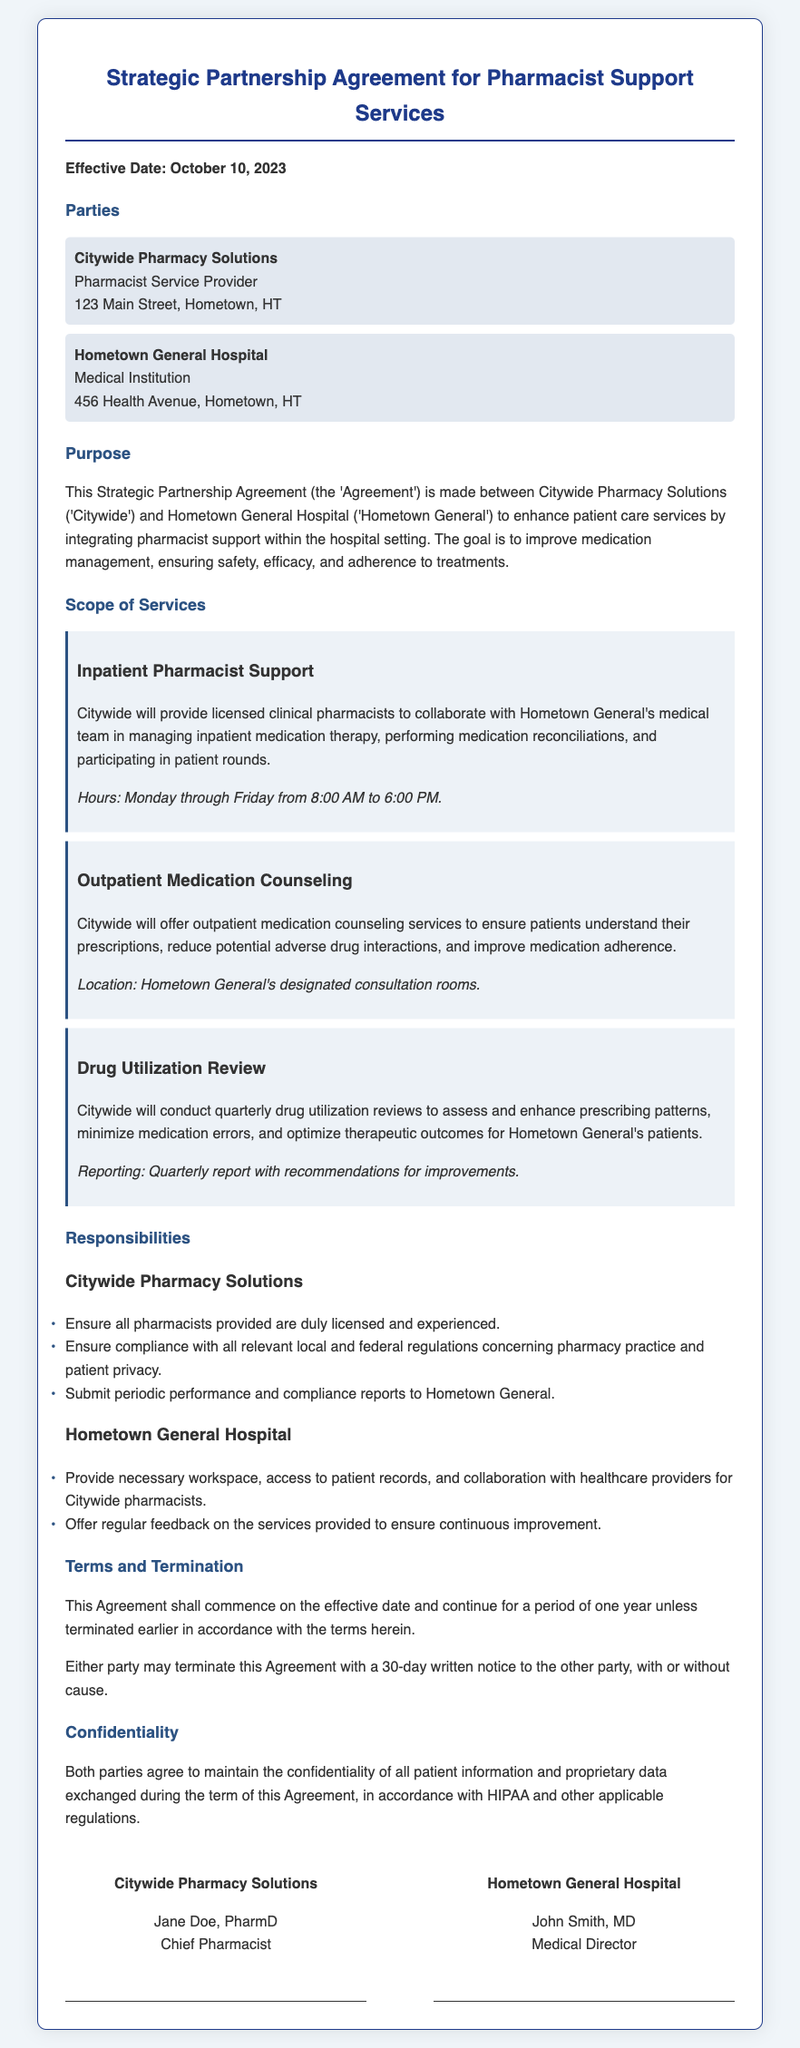What is the effective date of the agreement? The effective date is clearly stated at the beginning of the document as October 10, 2023.
Answer: October 10, 2023 Who is the Chief Pharmacist at Citywide Pharmacy Solutions? The document specifies that Jane Doe, PharmD, holds the position of Chief Pharmacist.
Answer: Jane Doe, PharmD How often will drug utilization reviews be conducted? The agreement outlines that these reviews will occur quarterly.
Answer: Quarterly What is one of the responsibilities of Hometown General Hospital? The document lists providing necessary workspace and access to patient records as a responsibility of Hometown General.
Answer: Provide necessary workspace What is the duration of the agreement? The terms state that the agreement continues for a period of one year unless terminated earlier.
Answer: One year What is required for either party to terminate the agreement? The document states that a 30-day written notice is required for termination by either party.
Answer: 30-day written notice Where is Citywide Pharmacy Solutions located? The document provides the address of Citywide Pharmacy Solutions as 123 Main Street, Hometown, HT.
Answer: 123 Main Street, Hometown, HT What is the location for outpatient medication counseling services? The agreement mentions that outpatient medication counseling will take place in designated consultation rooms at Hometown General.
Answer: Hometown General's designated consultation rooms What must Citywide ensure about the pharmacists they provide? The document specifies that Citywide must ensure all pharmacists provided are duly licensed and experienced.
Answer: Duly licensed and experienced 